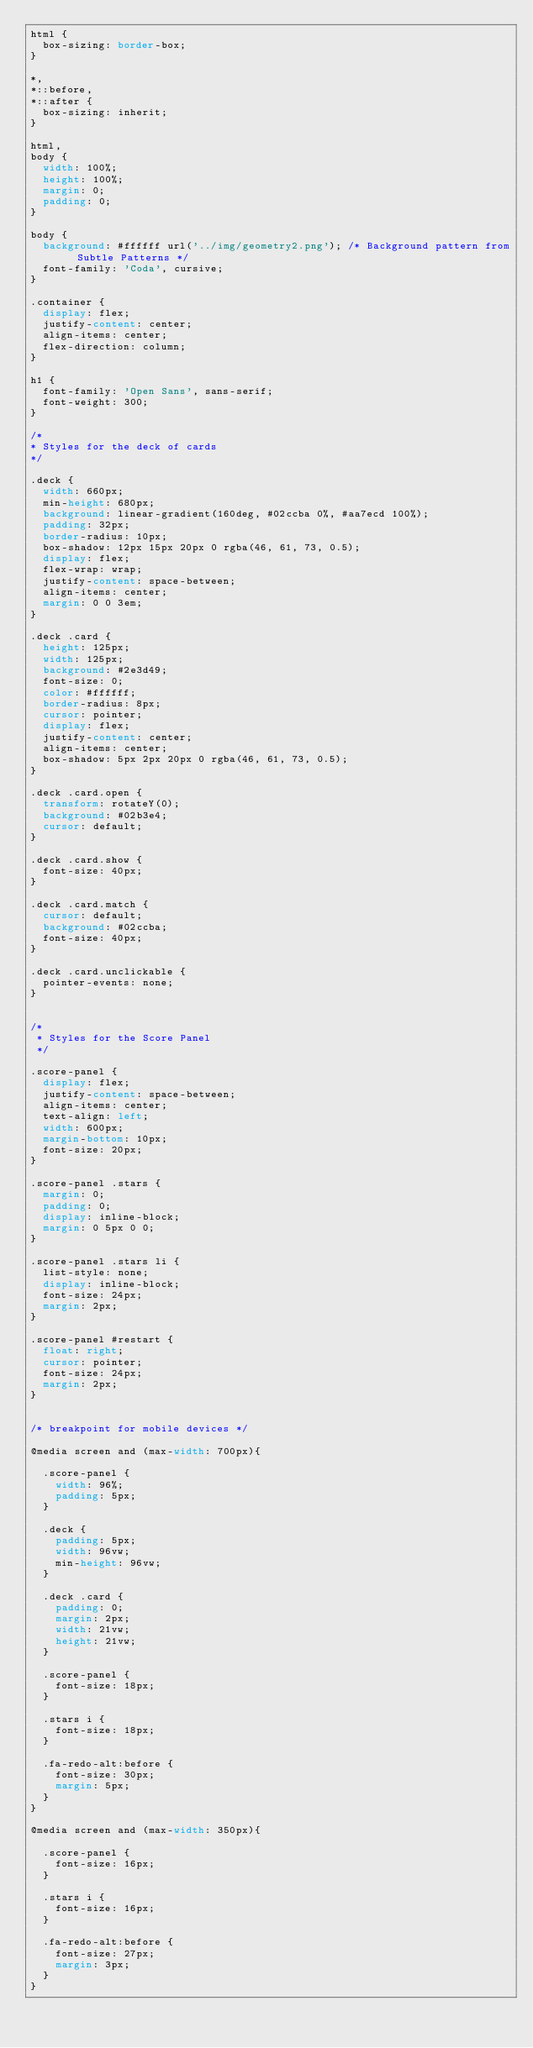Convert code to text. <code><loc_0><loc_0><loc_500><loc_500><_CSS_>html {
  box-sizing: border-box;
}

*,
*::before,
*::after {
  box-sizing: inherit;
}

html,
body {
  width: 100%;
  height: 100%;
  margin: 0;
  padding: 0;
}

body {
  background: #ffffff url('../img/geometry2.png'); /* Background pattern from Subtle Patterns */
  font-family: 'Coda', cursive;
}

.container {
  display: flex;
  justify-content: center;
  align-items: center;
  flex-direction: column;
}

h1 {
  font-family: 'Open Sans', sans-serif;
  font-weight: 300;
}

/*
* Styles for the deck of cards
*/

.deck {
  width: 660px;
  min-height: 680px;
  background: linear-gradient(160deg, #02ccba 0%, #aa7ecd 100%);
  padding: 32px;
  border-radius: 10px;
  box-shadow: 12px 15px 20px 0 rgba(46, 61, 73, 0.5);
  display: flex;
  flex-wrap: wrap;
  justify-content: space-between;
  align-items: center;
  margin: 0 0 3em;
}

.deck .card {
  height: 125px;
  width: 125px;
  background: #2e3d49;
  font-size: 0;
  color: #ffffff;
  border-radius: 8px;
  cursor: pointer;
  display: flex;
  justify-content: center;
  align-items: center;
  box-shadow: 5px 2px 20px 0 rgba(46, 61, 73, 0.5);
}

.deck .card.open {
  transform: rotateY(0);
  background: #02b3e4;
  cursor: default;
}

.deck .card.show {
  font-size: 40px;
}

.deck .card.match {
  cursor: default;
  background: #02ccba;
  font-size: 40px;
}

.deck .card.unclickable {
  pointer-events: none;
}


/*
 * Styles for the Score Panel
 */

.score-panel {
  display: flex;
  justify-content: space-between;
  align-items: center;
  text-align: left;
  width: 600px;
  margin-bottom: 10px;
  font-size: 20px;
}

.score-panel .stars {
  margin: 0;
  padding: 0;
  display: inline-block;
  margin: 0 5px 0 0;
}

.score-panel .stars li {
  list-style: none;
  display: inline-block;
  font-size: 24px;
  margin: 2px;
}

.score-panel #restart {
  float: right;
  cursor: pointer;
  font-size: 24px;
  margin: 2px;
}


/* breakpoint for mobile devices */

@media screen and (max-width: 700px){

  .score-panel {
    width: 96%;
    padding: 5px;
  }

  .deck {
    padding: 5px;
    width: 96vw;
    min-height: 96vw;
  }

  .deck .card {
    padding: 0;
    margin: 2px;
    width: 21vw;
    height: 21vw;
  }

  .score-panel {
    font-size: 18px;
  }

  .stars i {
    font-size: 18px;
  }

  .fa-redo-alt:before {
    font-size: 30px;
    margin: 5px;
  }
}

@media screen and (max-width: 350px){

  .score-panel {
    font-size: 16px;
  }

  .stars i {
    font-size: 16px;
  }

  .fa-redo-alt:before {
    font-size: 27px;
    margin: 3px;
  }
}
</code> 